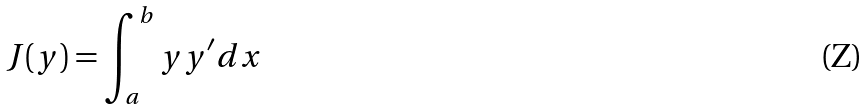<formula> <loc_0><loc_0><loc_500><loc_500>J ( y ) = \int _ { a } ^ { b } y y ^ { \prime } d x</formula> 